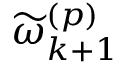Convert formula to latex. <formula><loc_0><loc_0><loc_500><loc_500>\widetilde { \omega } _ { k + 1 } ^ { \left ( p \right ) }</formula> 